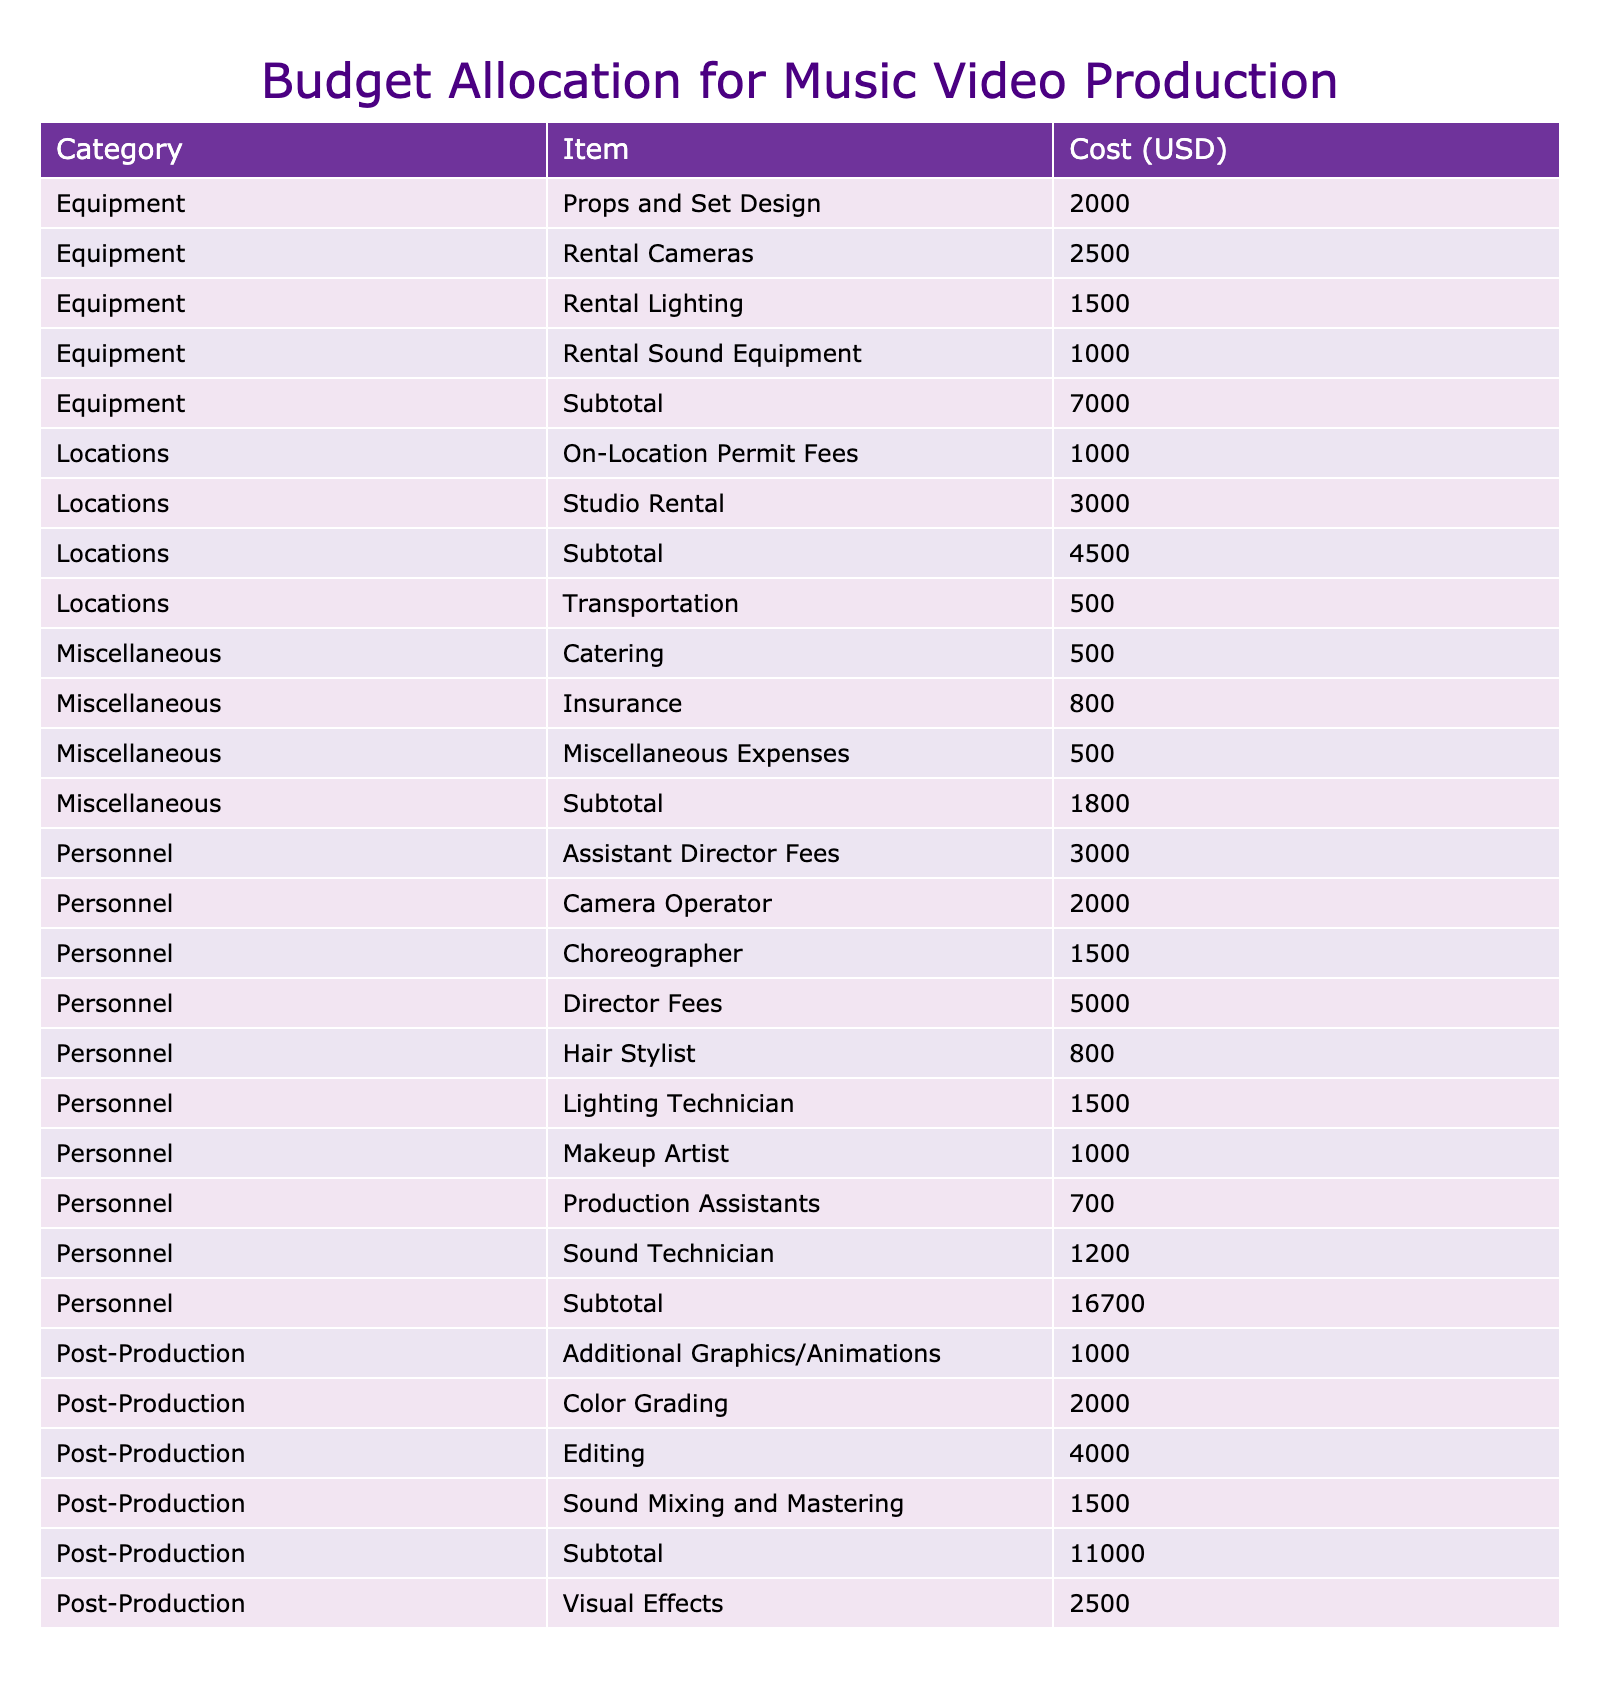What is the total cost for personnel in music video production? To find the total cost for personnel, we need to sum the costs of all personnel-related items. These are: Director Fees (5000), Assistant Director Fees (3000), Camera Operator (2000), Lighting Technician (1500), Sound Technician (1200), Makeup Artist (1000), Hair Stylist (800), Choreographer (1500), and Production Assistants (700). Adding these together gives us 5000 + 3000 + 2000 + 1500 + 1200 + 1000 + 800 + 1500 + 700 = 18000.
Answer: 18000 How much is spent on equipment compared to personnel? First, we calculate the total cost for equipment by adding: Rental Cameras (2500), Rental Lighting (1500), Rental Sound Equipment (1000), and Props and Set Design (2000). This gives us a total of 2500 + 1500 + 1000 + 2000 = 7000 for equipment. Personnel cost is 18000 as calculated previously. Comparing the two amounts shows that personnel costs are higher than equipment costs: 18000 - 7000 = 11000 difference.
Answer: Personnel costs are higher by 11000 Is the total cost for post-production higher than for locations? The total for post-production can be summed up as: Editing (4000), Color Grading (2000), Visual Effects (2500), Sound Mixing and Mastering (1500), and Additional Graphics/Animations (1000). This amounts to 4000 + 2000 + 2500 + 1500 + 1000 = 11000. For locations, we add: Studio Rental (3000), On-Location Permit Fees (1000), and Transportation (500) for a total of 3000 + 1000 + 500 = 4500. Since 11000 is greater than 4500, post-production costs are indeed higher.
Answer: Yes What is the average cost for personnel? To find the average cost, we need to calculate the total personnel cost (18000) and divide it by the number of personnel items, which is 9. So, we compute 18000 / 9 = 2000. This means the average cost per personnel item is 2000.
Answer: 2000 Are there more personnel-related costs or post-production costs? Counting the rows, personnel has 9 items listed, while post-production has 5 items. Therefore, personnel-related costs are greater in number than post-production costs.
Answer: Yes What is the grand total for the entire budget? The grand total is calculated by summing all costs in the table. Starting from the total of 18000 for personnel, 7000 for equipment, 4500 for locations, and 11000 for post-production gives us: 18000 + 7000 + 4500 + 11000 + 1300 (catering, insurance, miscellaneous expenses) = 46000. Thus, the grand total is 46000.
Answer: 46000 Which category has the highest single item cost? By examining the costs, the highest values are: Director Fees (5000), Editing (4000), and Studio Rental (3000). The highest among these is 5000 from Director Fees, indicating this is the single highest cost in the budget.
Answer: Personnel has the highest single cost of 5000 How much is allocated for miscellaneous expenses? The miscellaneous category has three items listed: Catering (500), Insurance (800), and Miscellaneous Expenses (500). Summing these amounts gives us 500 + 800 + 500 = 1800 for miscellaneous expenses.
Answer: 1800 